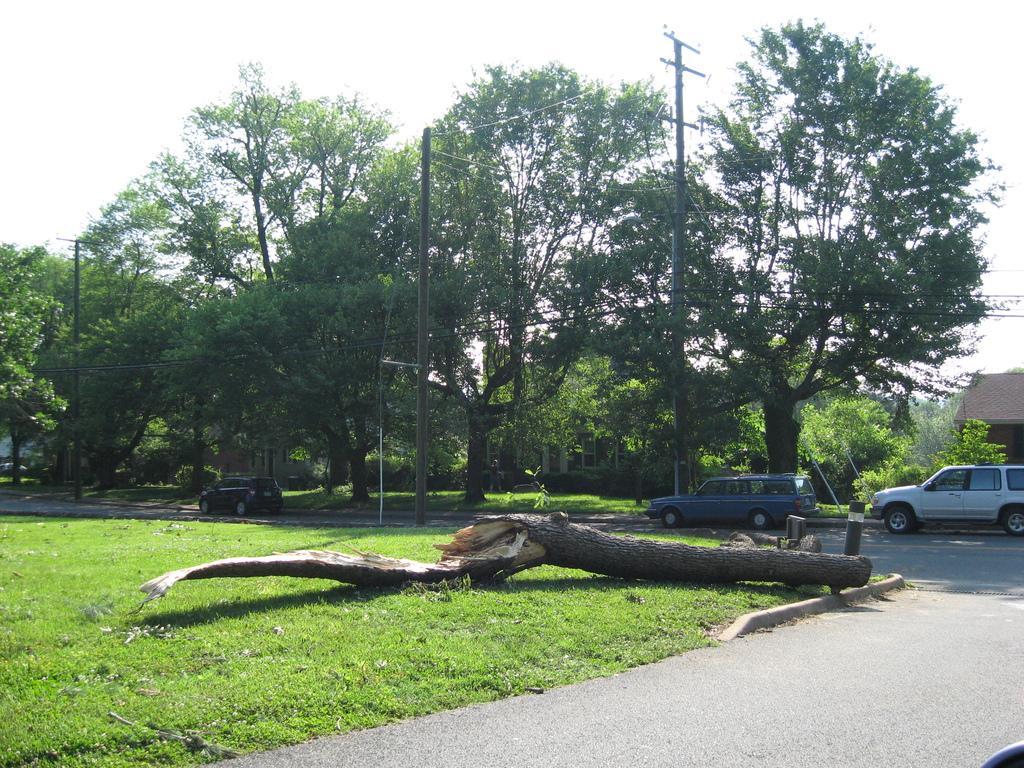Describe this image in one or two sentences. We can see vehicles on the road, wooden object, grass, poles and wires. In the background we can see trees, house and sky. 